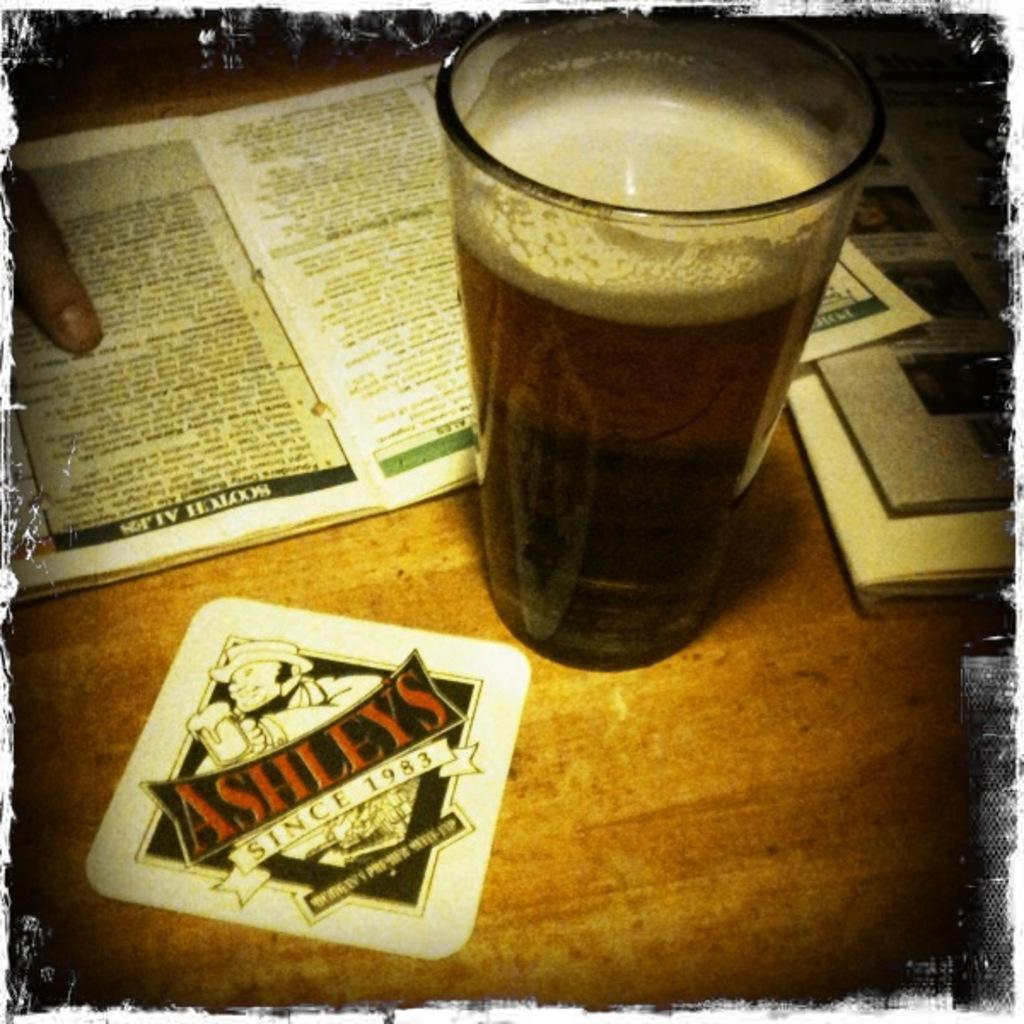<image>
Share a concise interpretation of the image provided. A table at a restaurant, showing a beer, a person pointing at a menu and a coaster that says Ashley's since 1983 